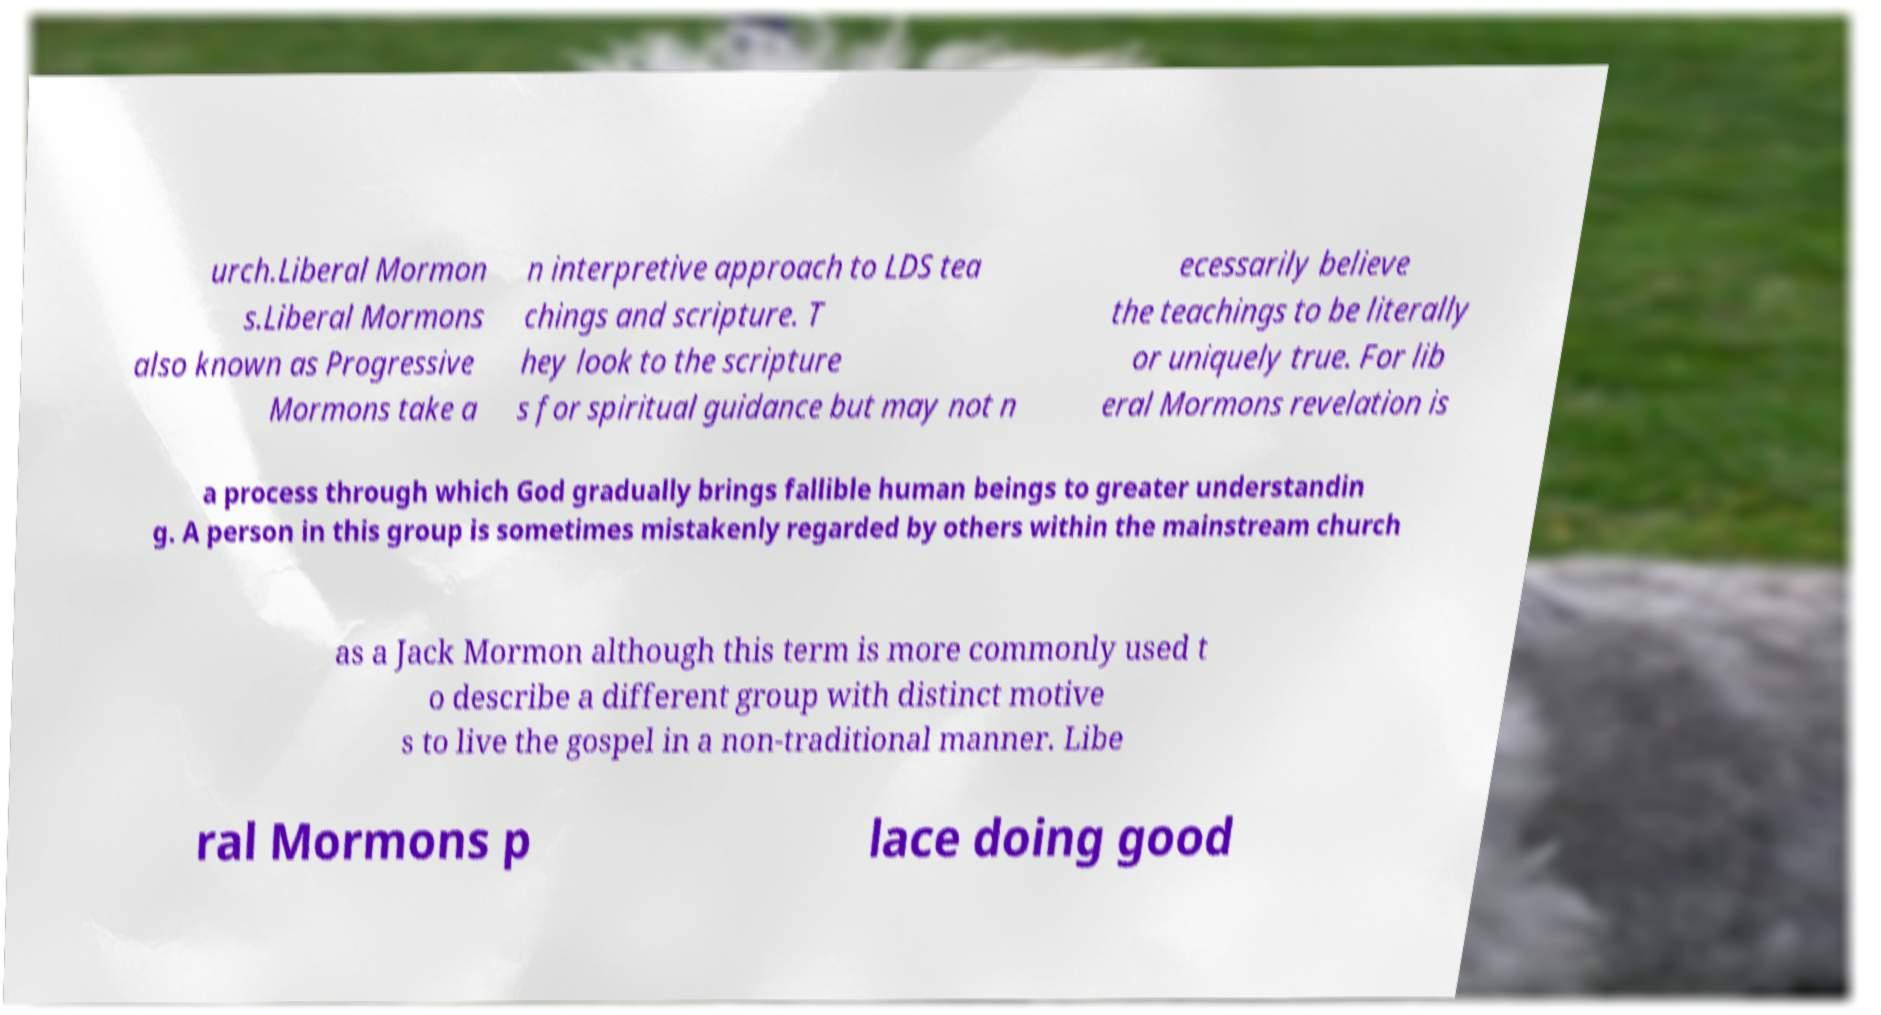Could you assist in decoding the text presented in this image and type it out clearly? urch.Liberal Mormon s.Liberal Mormons also known as Progressive Mormons take a n interpretive approach to LDS tea chings and scripture. T hey look to the scripture s for spiritual guidance but may not n ecessarily believe the teachings to be literally or uniquely true. For lib eral Mormons revelation is a process through which God gradually brings fallible human beings to greater understandin g. A person in this group is sometimes mistakenly regarded by others within the mainstream church as a Jack Mormon although this term is more commonly used t o describe a different group with distinct motive s to live the gospel in a non-traditional manner. Libe ral Mormons p lace doing good 